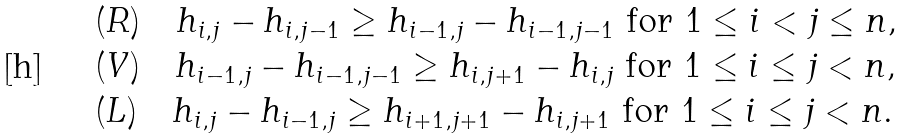Convert formula to latex. <formula><loc_0><loc_0><loc_500><loc_500>& ( R ) \quad h _ { i , j } - h _ { i , j - 1 } \geq h _ { i - 1 , j } - h _ { i - 1 , j - 1 } \text { for } 1 \leq i < j \leq n , \\ & ( V ) \quad h _ { i - 1 , j } - h _ { i - 1 , j - 1 } \geq h _ { i , j + 1 } - h _ { i , j } \text { for } 1 \leq i \leq j < n , \\ & ( L ) \quad h _ { i , j } - h _ { i - 1 , j } \geq h _ { i + 1 , j + 1 } - h _ { i , j + 1 } \text { for } 1 \leq i \leq j < n .</formula> 